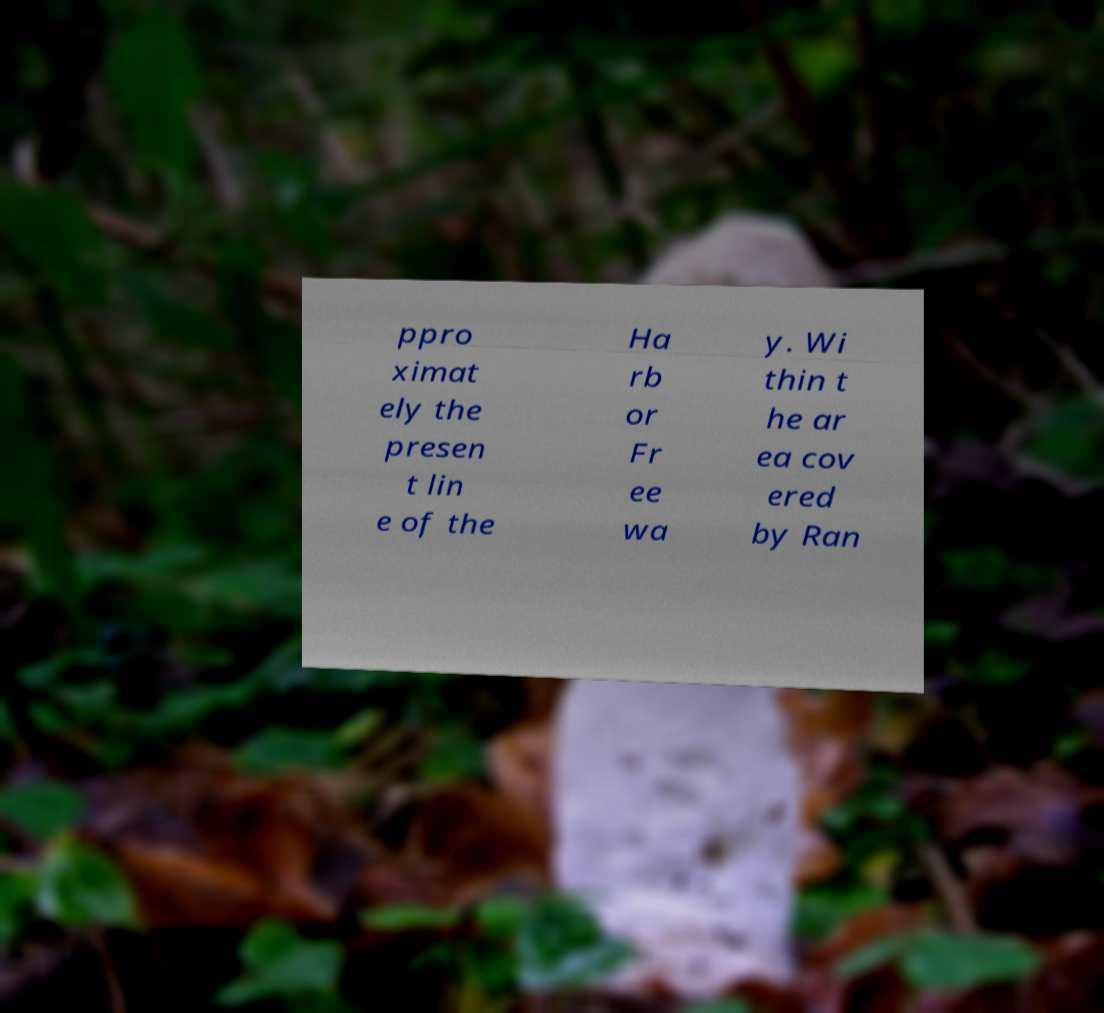Can you read and provide the text displayed in the image?This photo seems to have some interesting text. Can you extract and type it out for me? ppro ximat ely the presen t lin e of the Ha rb or Fr ee wa y. Wi thin t he ar ea cov ered by Ran 